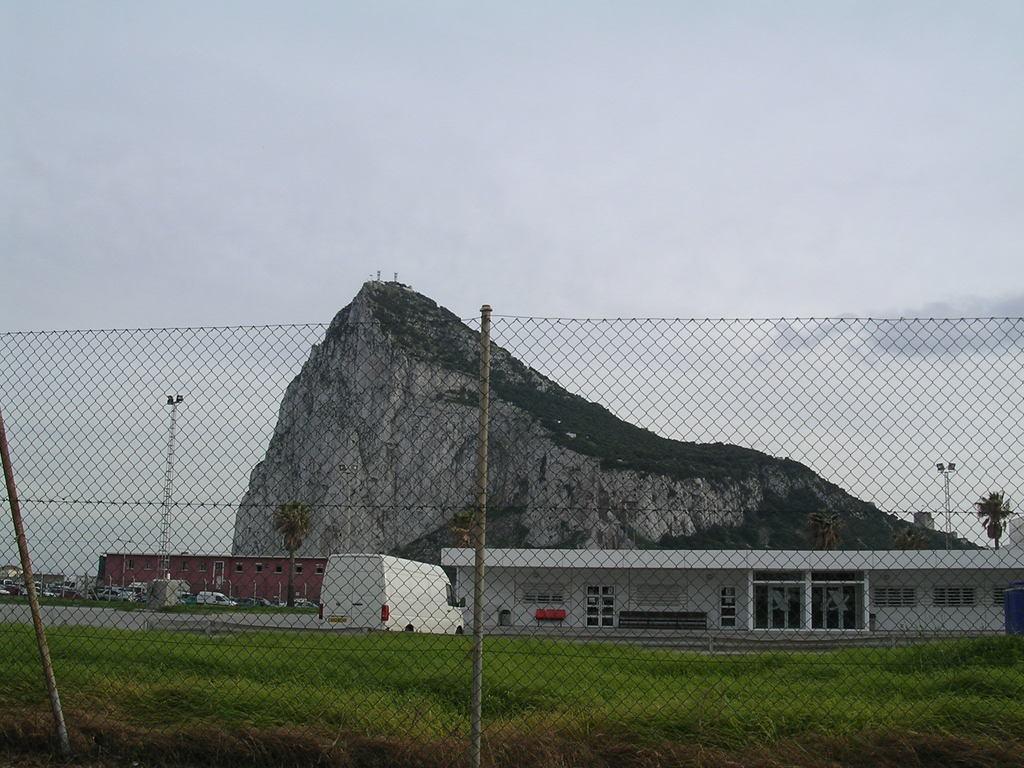How would you summarize this image in a sentence or two? In the foreground I can see a fence, grass, houses, vehicles on the road and a tower. In the background I can see a mountain and the sky. This image is taken during a day. 